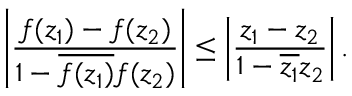Convert formula to latex. <formula><loc_0><loc_0><loc_500><loc_500>\left | { \frac { f ( z _ { 1 } ) - f ( z _ { 2 } ) } { 1 - { \overline { { f ( z _ { 1 } ) } } } f ( z _ { 2 } ) } } \right | \leq \left | { \frac { z _ { 1 } - z _ { 2 } } { 1 - { \overline { { z _ { 1 } } } } z _ { 2 } } } \right | .</formula> 